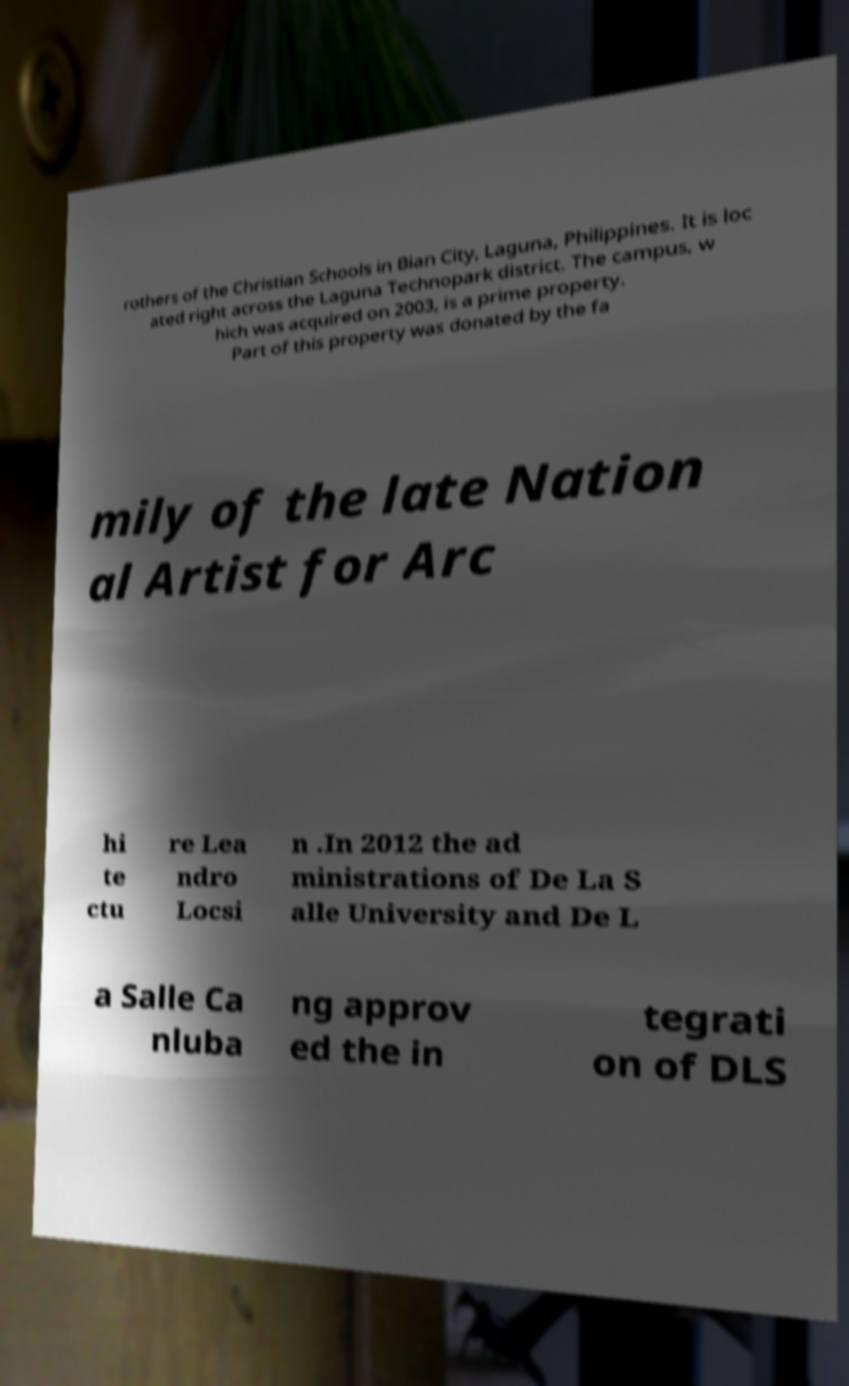I need the written content from this picture converted into text. Can you do that? rothers of the Christian Schools in Bian City, Laguna, Philippines. It is loc ated right across the Laguna Technopark district. The campus, w hich was acquired on 2003, is a prime property. Part of this property was donated by the fa mily of the late Nation al Artist for Arc hi te ctu re Lea ndro Locsi n .In 2012 the ad ministrations of De La S alle University and De L a Salle Ca nluba ng approv ed the in tegrati on of DLS 